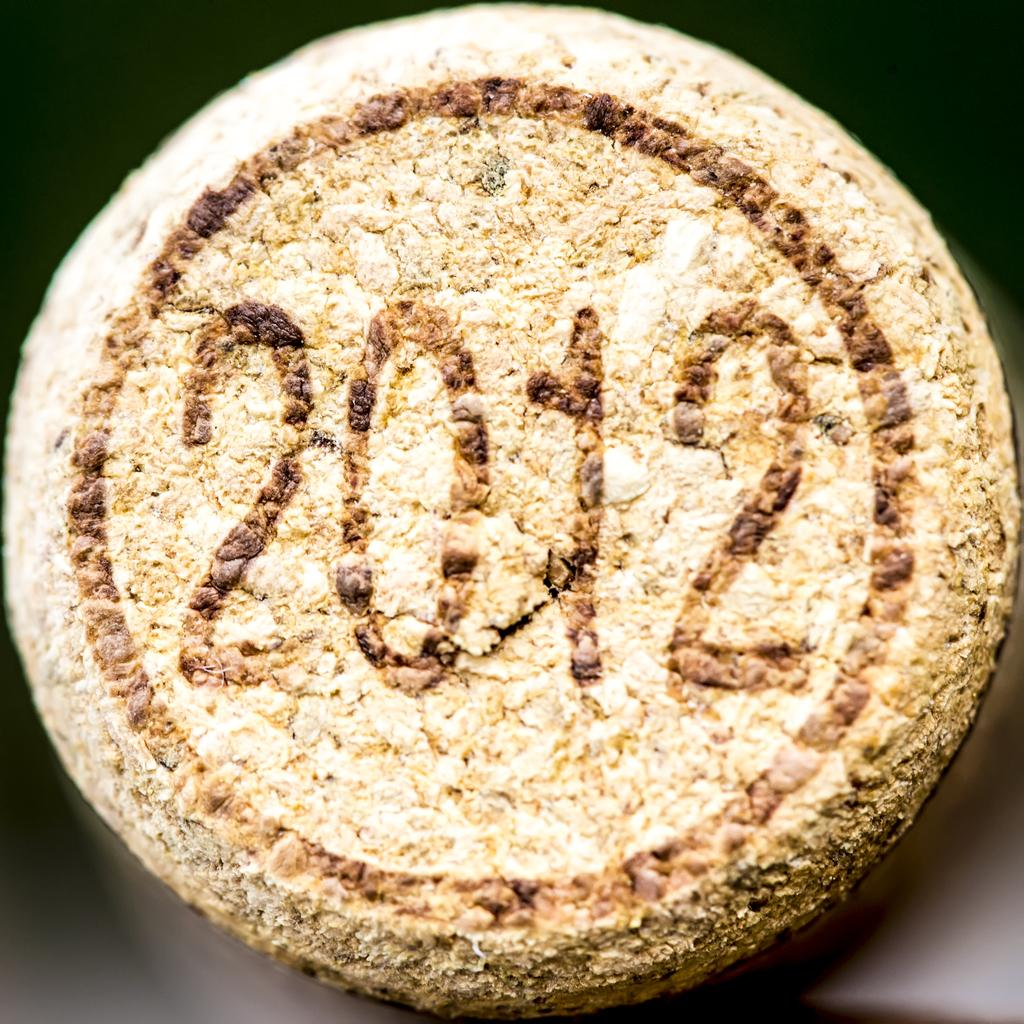What is the main subject in the image? There is an object in the image. What can be observed on the object? The object has numbers on it. Is there a ghost visible in the image? No, there is no ghost present in the image. What type of roll is being used to interact with the object in the image? There is no roll present in the image; it only features an object with numbers on it. 